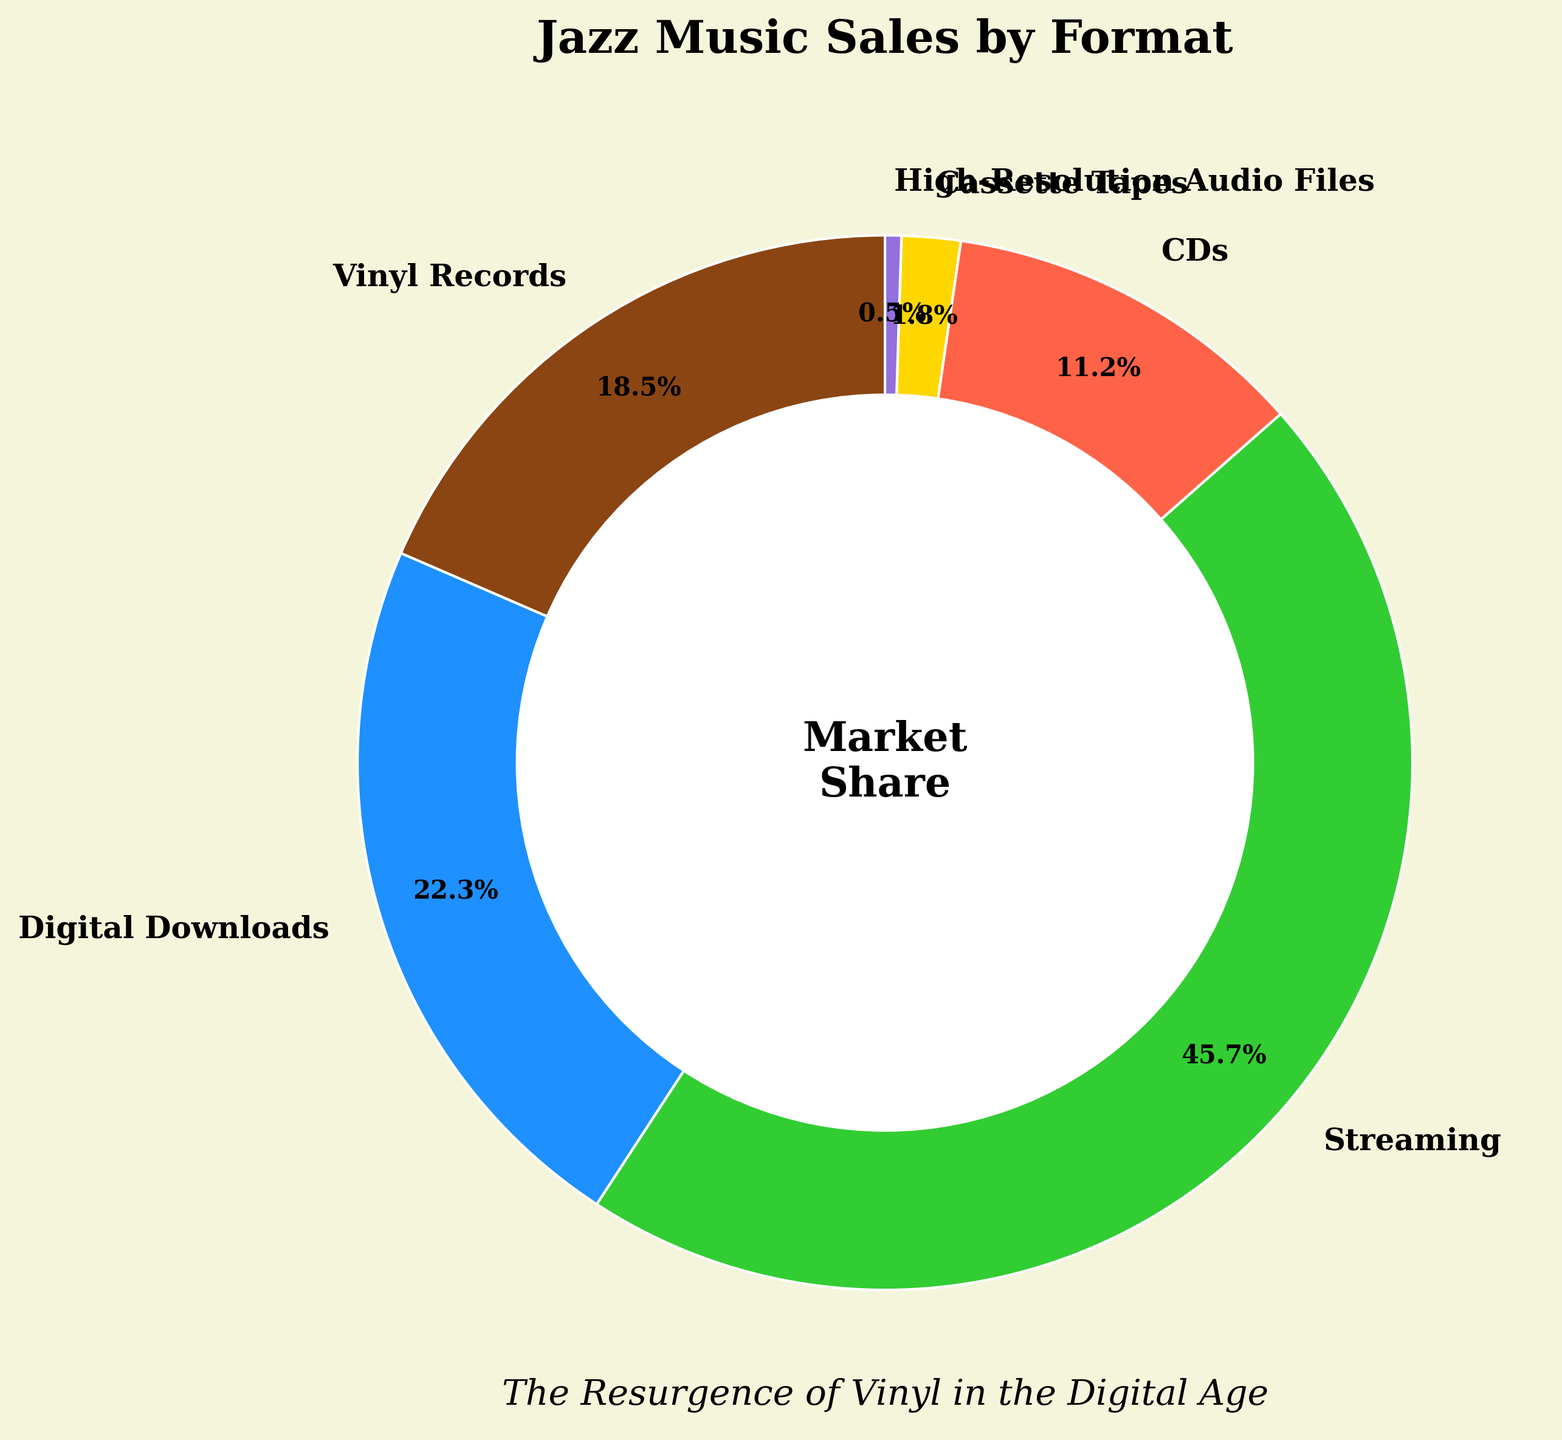What's the market share of vinyl records? To determine the market share of vinyl records, we simply look at the label and the percentage value on the pie chart. The slice labeled "Vinyl Records" shows 18.5%.
Answer: 18.5% Which format has the highest market share? To identify the format with the highest market share, we look for the largest slice in the pie chart and its label. The largest slice corresponds to "Streaming" with a market share of 45.7%.
Answer: Streaming How does the market share of CDs compare to that of cassette tapes? We examine the pie chart to find the values corresponding to "CDs" and "Cassette Tapes." CDs have a market share of 11.2%, while cassette tapes have 1.8%. Thus, CDs have a significantly higher market share.
Answer: CDs have a higher market share What is the combined market share of digital downloads and streaming? To calculate the combined market share, we add the market shares of both formats: Digital Downloads (22.3%) and Streaming (45.7%). The sum is 22.3 + 45.7 = 68.0%.
Answer: 68.0% Which format has the smallest market share? To determine the smallest market share, we look for the smallest slice in the pie chart and its label. The smallest slice is "High-Resolution Audio Files" with a market share of 0.5%.
Answer: High-Resolution Audio Files What is the difference between the market share of vinyl records and digital downloads? We find the values for vinyl records (18.5%) and digital downloads (22.3%) from the pie chart. The difference is calculated as 22.3 - 18.5 = 3.8%.
Answer: 3.8% What is the total market share of all physical formats combined? Physical formats here include Vinyl Records (18.5%), CDs (11.2%), and Cassette Tapes (1.8%). Add these values to get 18.5 + 11.2 + 1.8 = 31.5%.
Answer: 31.5% How does the market share of high-resolution audio files visually compare to other formats? By looking at the size of the slice representing high-resolution audio files, we see it's much smaller relative to other slices in the pie chart. This indicates it has a very minor share.
Answer: It is much smaller Are digital downloads more popular than CDs based on the chart? Check the market shares labeled for Digital Downloads (22.3%) and CDs (11.2%) in the chart. Since 22.3% > 11.2%, digital downloads are indeed more popular than CDs.
Answer: Yes What portion of the chart is occupied by analog formats (vinyl records and cassette tapes)? We find the market share percentages for vinyl records (18.5%) and cassette tapes (1.8%). Adding these gives 18.5 + 1.8 = 20.3%.
Answer: 20.3% 